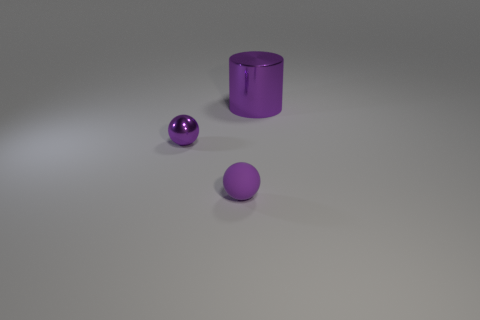There is a big object that is the same color as the metal sphere; what material is it?
Offer a terse response. Metal. Are there any other things that have the same shape as the large metallic thing?
Your answer should be compact. No. What is the shape of the purple thing that is the same size as the purple rubber sphere?
Keep it short and to the point. Sphere. Is there a tiny yellow object that has the same shape as the small purple matte thing?
Your response must be concise. No. Is the big thing made of the same material as the purple thing that is in front of the shiny sphere?
Your answer should be compact. No. The tiny purple sphere on the right side of the purple sphere that is on the left side of the purple matte thing is made of what material?
Provide a short and direct response. Rubber. Is the number of balls on the left side of the metallic ball greater than the number of tiny matte balls?
Make the answer very short. No. Are there any purple matte objects?
Make the answer very short. Yes. There is a small object in front of the tiny purple metallic thing; what color is it?
Give a very brief answer. Purple. What is the material of the other purple thing that is the same size as the purple rubber thing?
Keep it short and to the point. Metal. 